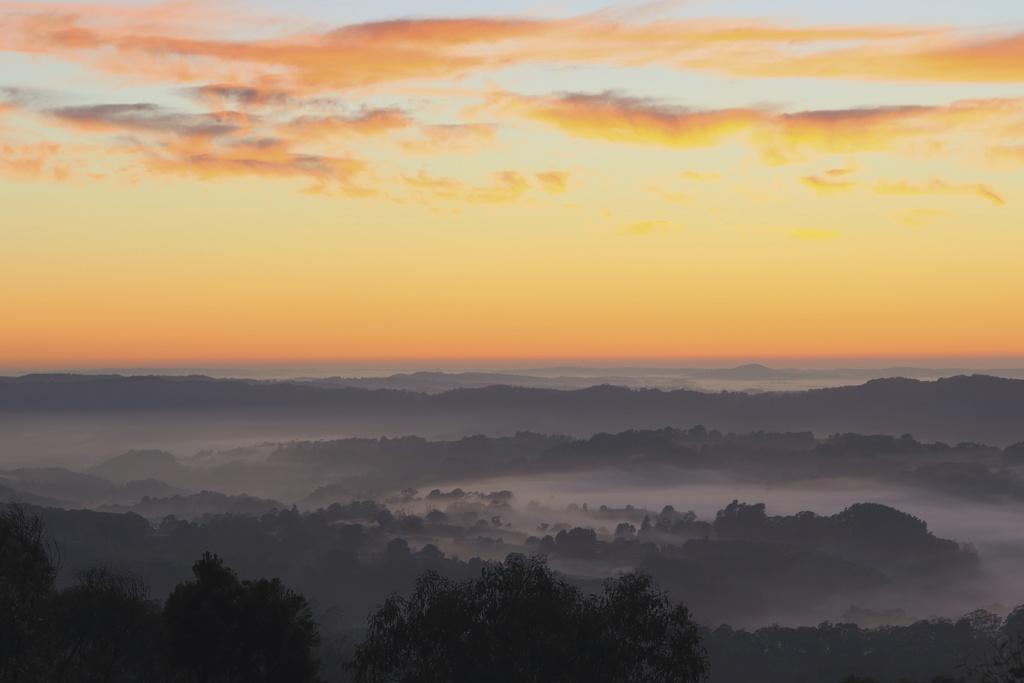What type of landscape is depicted in the image? The image features hills. What can be seen at the bottom of the hills? There are trees at the bottom of the image. What is visible at the top of the image? The sky is visible at the top of the image. How many jellyfish can be seen swimming in the water near the hills? There is no water or jellyfish present in the image; it features hills and trees. 